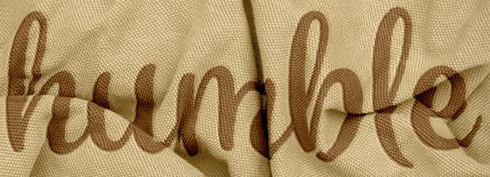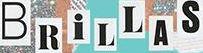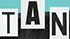What text appears in these images from left to right, separated by a semicolon? humble; BRiLLAS; TAN 